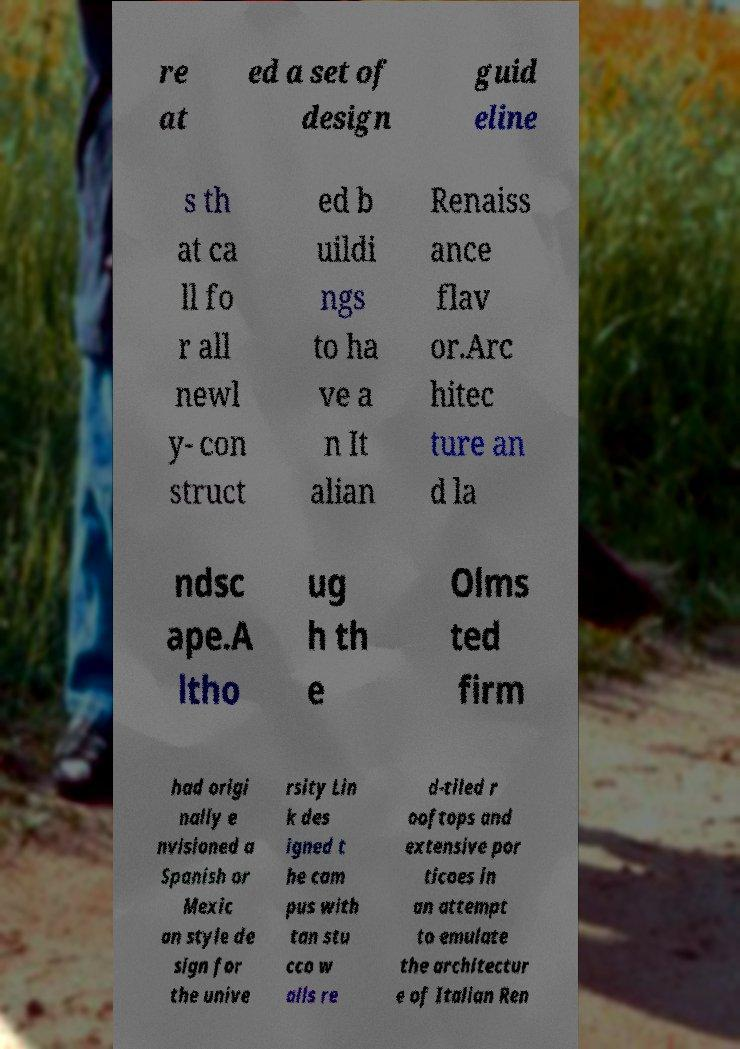There's text embedded in this image that I need extracted. Can you transcribe it verbatim? re at ed a set of design guid eline s th at ca ll fo r all newl y- con struct ed b uildi ngs to ha ve a n It alian Renaiss ance flav or.Arc hitec ture an d la ndsc ape.A ltho ug h th e Olms ted firm had origi nally e nvisioned a Spanish or Mexic an style de sign for the unive rsity Lin k des igned t he cam pus with tan stu cco w alls re d-tiled r ooftops and extensive por ticoes in an attempt to emulate the architectur e of Italian Ren 